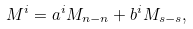Convert formula to latex. <formula><loc_0><loc_0><loc_500><loc_500>M ^ { i } = a ^ { i } M _ { n - n } + b ^ { i } M _ { s - s } ,</formula> 